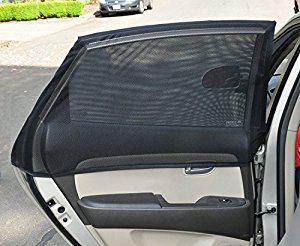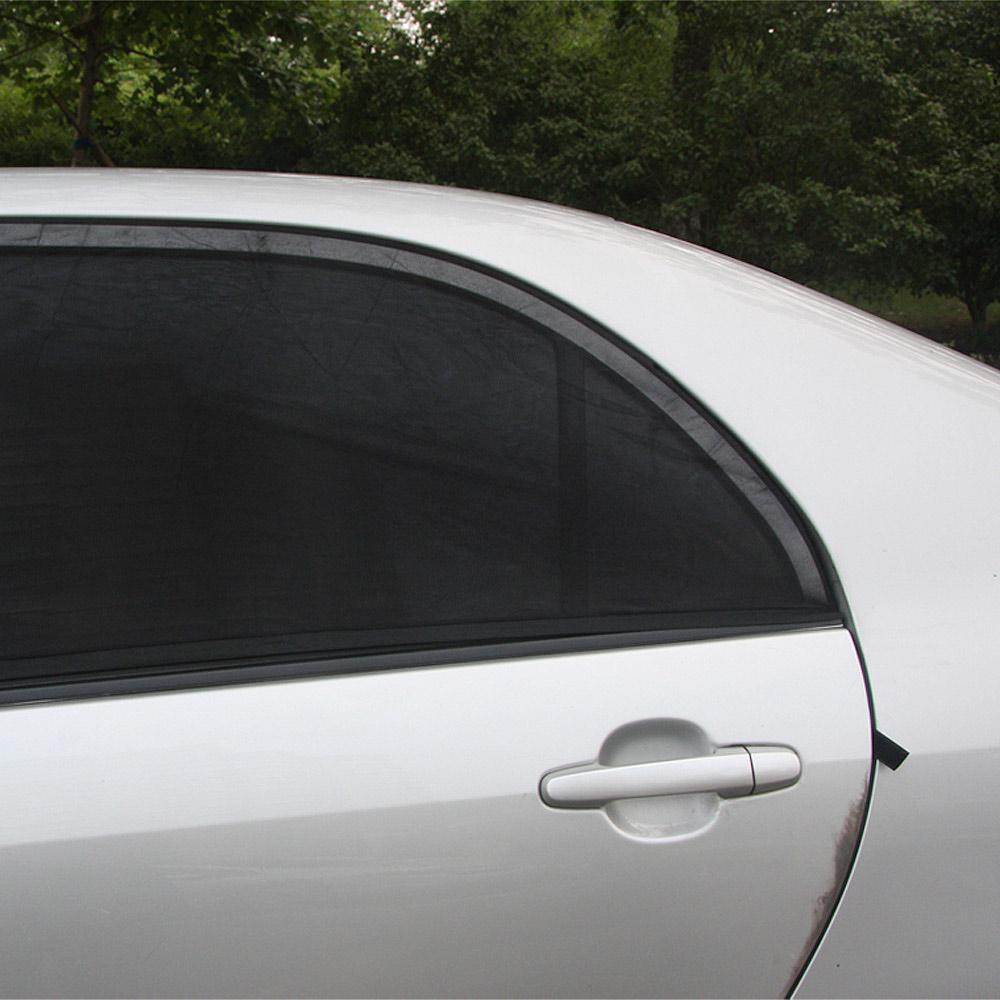The first image is the image on the left, the second image is the image on the right. Examine the images to the left and right. Is the description "In the left image the door is open and you can see a second car in the background." accurate? Answer yes or no. Yes. 